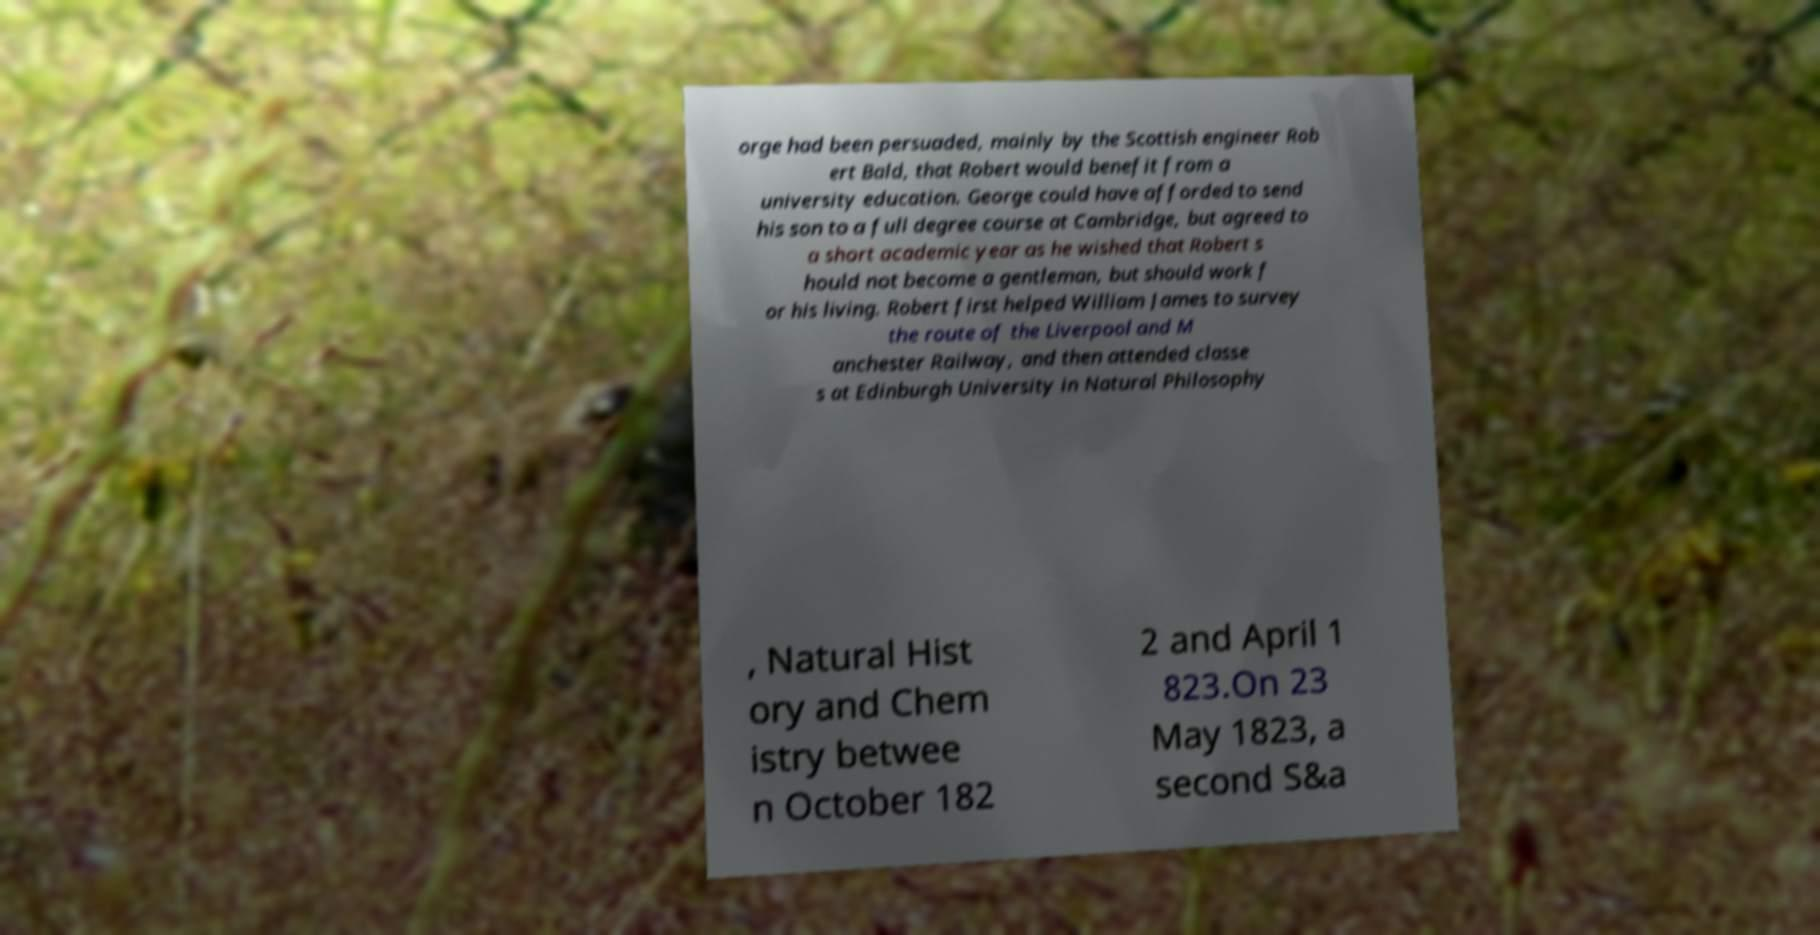For documentation purposes, I need the text within this image transcribed. Could you provide that? orge had been persuaded, mainly by the Scottish engineer Rob ert Bald, that Robert would benefit from a university education. George could have afforded to send his son to a full degree course at Cambridge, but agreed to a short academic year as he wished that Robert s hould not become a gentleman, but should work f or his living. Robert first helped William James to survey the route of the Liverpool and M anchester Railway, and then attended classe s at Edinburgh University in Natural Philosophy , Natural Hist ory and Chem istry betwee n October 182 2 and April 1 823.On 23 May 1823, a second S&a 